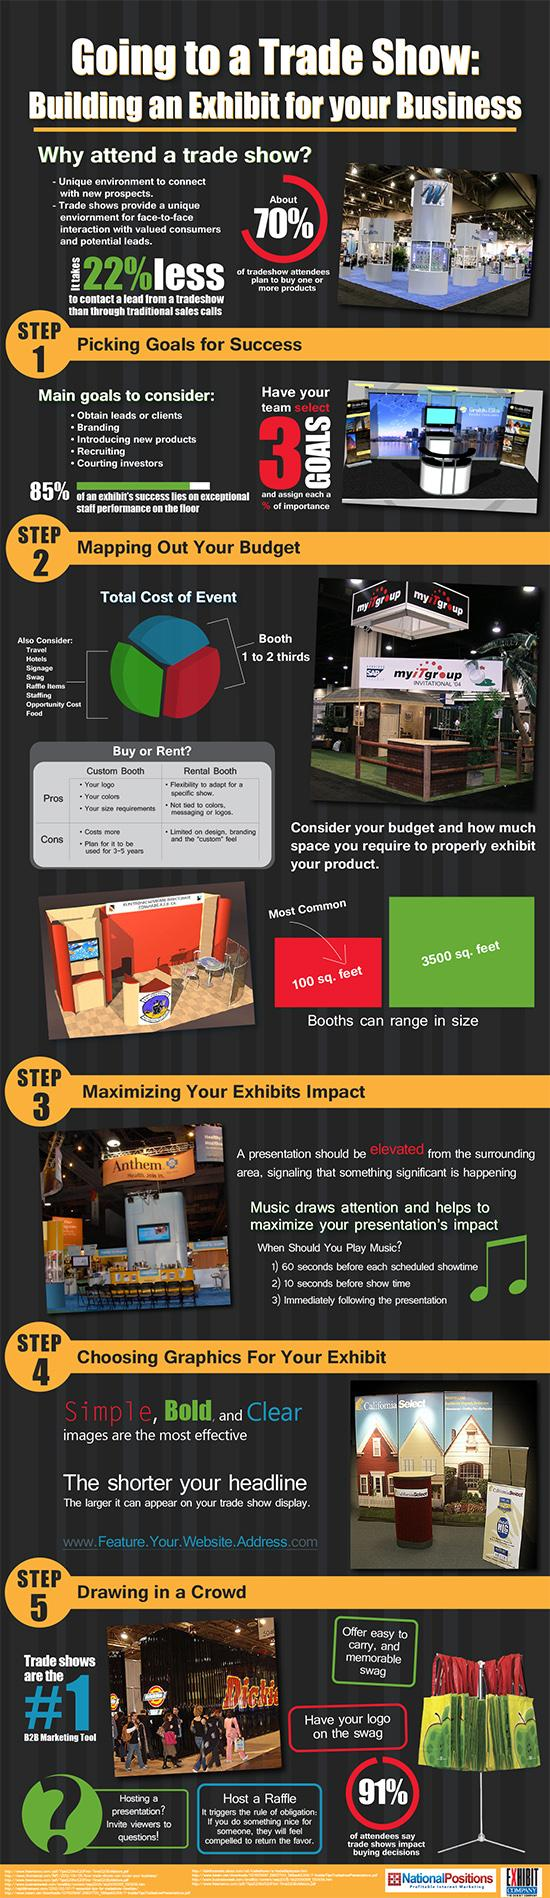Draw attention to some important aspects in this diagram. The most common booth size is 100 square feet. 